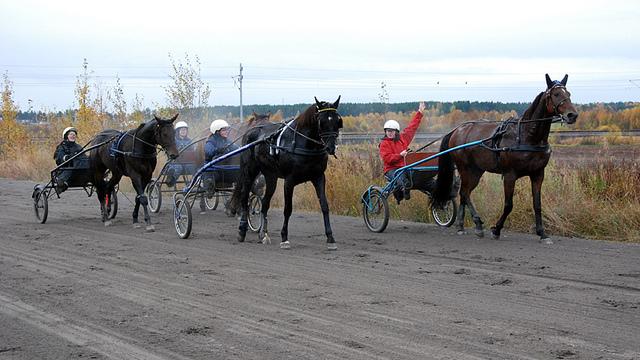What type of ancient Egyptian vehicle do these buggies resemble?
Quick response, please. Chariot. How many horses are there?
Quick response, please. 3. Which of the horses legs has white fur?
Concise answer only. None. How many wheels do these carts have?
Be succinct. 2. 